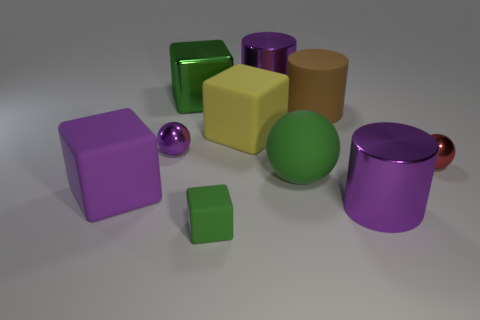Do the red thing and the green matte block have the same size?
Ensure brevity in your answer.  Yes. What number of other things are there of the same shape as the big purple rubber object?
Your answer should be compact. 3. What shape is the purple metallic object that is in front of the red thing?
Provide a succinct answer. Cylinder. Does the large metal object in front of the yellow matte block have the same shape as the green thing behind the large brown rubber object?
Provide a short and direct response. No. Are there the same number of red metallic things that are in front of the big green ball and big green shiny things?
Ensure brevity in your answer.  No. There is a big green thing that is the same shape as the large yellow thing; what material is it?
Provide a short and direct response. Metal. There is a metal thing on the right side of the purple cylinder in front of the large green metal thing; what shape is it?
Keep it short and to the point. Sphere. Is the material of the big purple cylinder behind the tiny purple metal ball the same as the yellow thing?
Provide a succinct answer. No. Are there the same number of red metallic objects in front of the large yellow rubber cube and shiny balls right of the tiny rubber block?
Give a very brief answer. Yes. There is a big block that is the same color as the tiny block; what is its material?
Offer a terse response. Metal. 